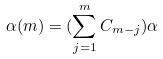<formula> <loc_0><loc_0><loc_500><loc_500>\alpha ( m ) = ( \sum _ { j = 1 } ^ { m } C _ { m - j } ) \alpha</formula> 